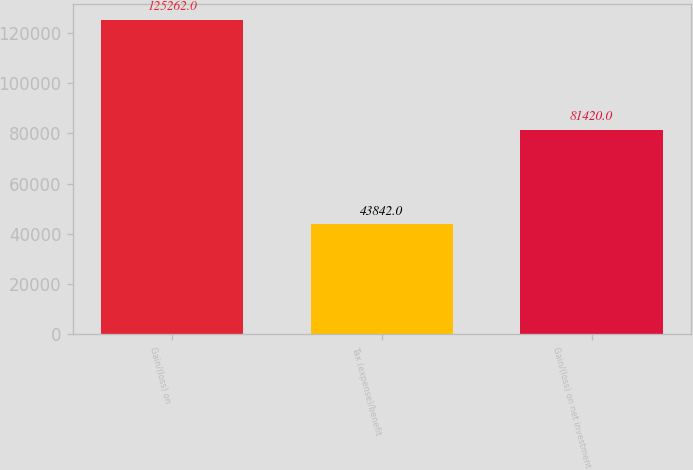Convert chart to OTSL. <chart><loc_0><loc_0><loc_500><loc_500><bar_chart><fcel>Gain/(loss) on<fcel>Tax (expense)/benefit<fcel>Gain/(loss) on net investment<nl><fcel>125262<fcel>43842<fcel>81420<nl></chart> 